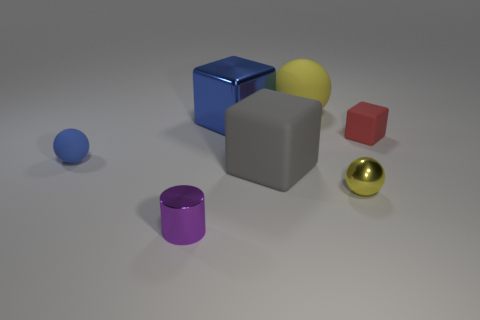What size is the sphere that is to the left of the yellow rubber sphere?
Provide a succinct answer. Small. Are there fewer spheres than objects?
Give a very brief answer. Yes. Is the material of the small yellow ball that is right of the blue rubber object the same as the block that is behind the red matte object?
Provide a succinct answer. Yes. What is the shape of the purple object right of the sphere left of the big cube that is in front of the tiny matte block?
Provide a succinct answer. Cylinder. How many cylinders have the same material as the purple thing?
Make the answer very short. 0. What number of blocks are behind the blue thing that is left of the blue block?
Offer a very short reply. 2. There is a tiny ball that is behind the yellow shiny thing; does it have the same color as the metal thing behind the tiny yellow sphere?
Offer a very short reply. Yes. What shape is the object that is right of the yellow rubber thing and behind the tiny metallic ball?
Offer a very short reply. Cube. Are there any large objects that have the same shape as the small red matte object?
Your answer should be compact. Yes. What is the shape of the metallic object that is the same size as the yellow rubber thing?
Your response must be concise. Cube. 